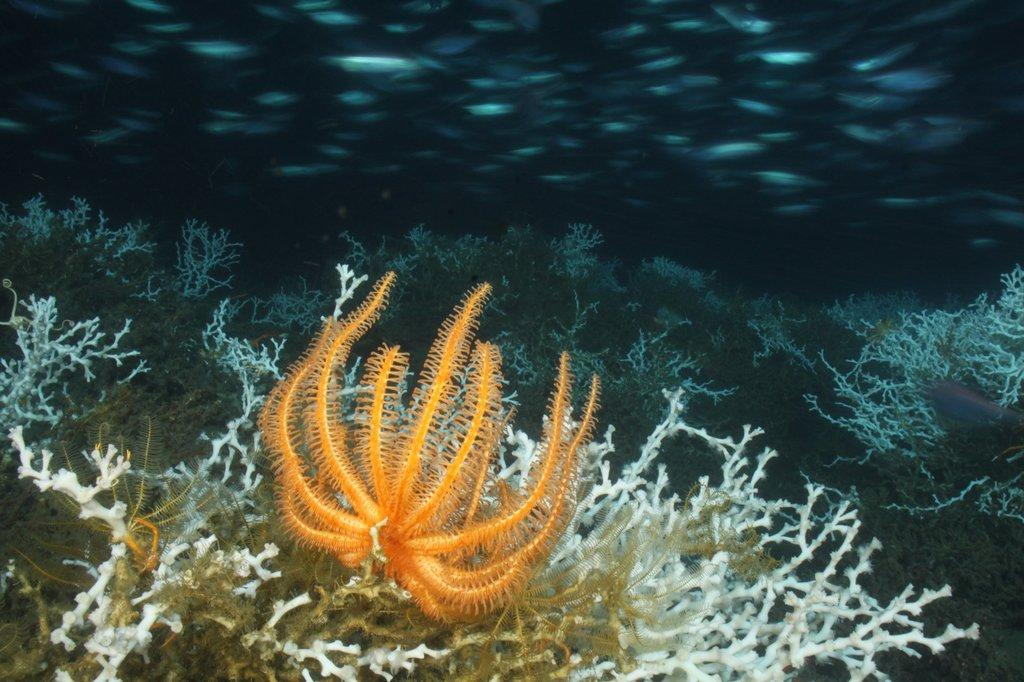What type of vegetation can be seen under the water in the image? There is seaweed visible under the water in the image. What type of leather is being used to spy on the seaweed in the image? There is no leather or spying activity present in the image; it simply shows seaweed underwater. 